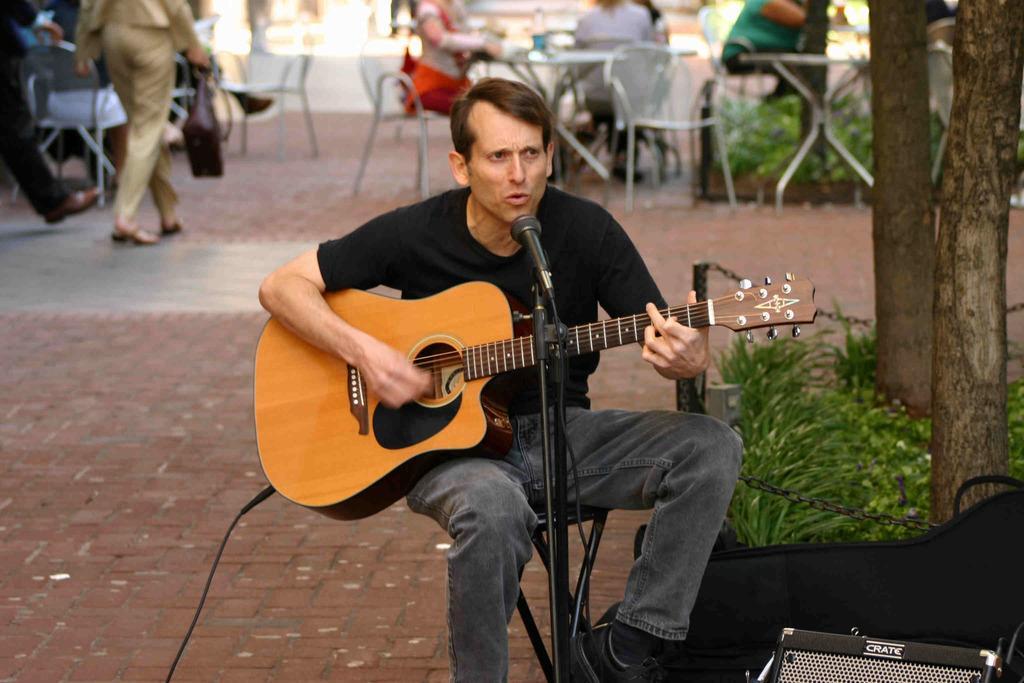Please provide a concise description of this image. In Front portion of a picture we can see one man sitting on chair in front of a mike , playing guitar and singing. Here we can see plants. On the background we can see few persons sitting on chairs in front of a table and on the table we can see a boole. We can see one person walking by holding a handbag in hand. 